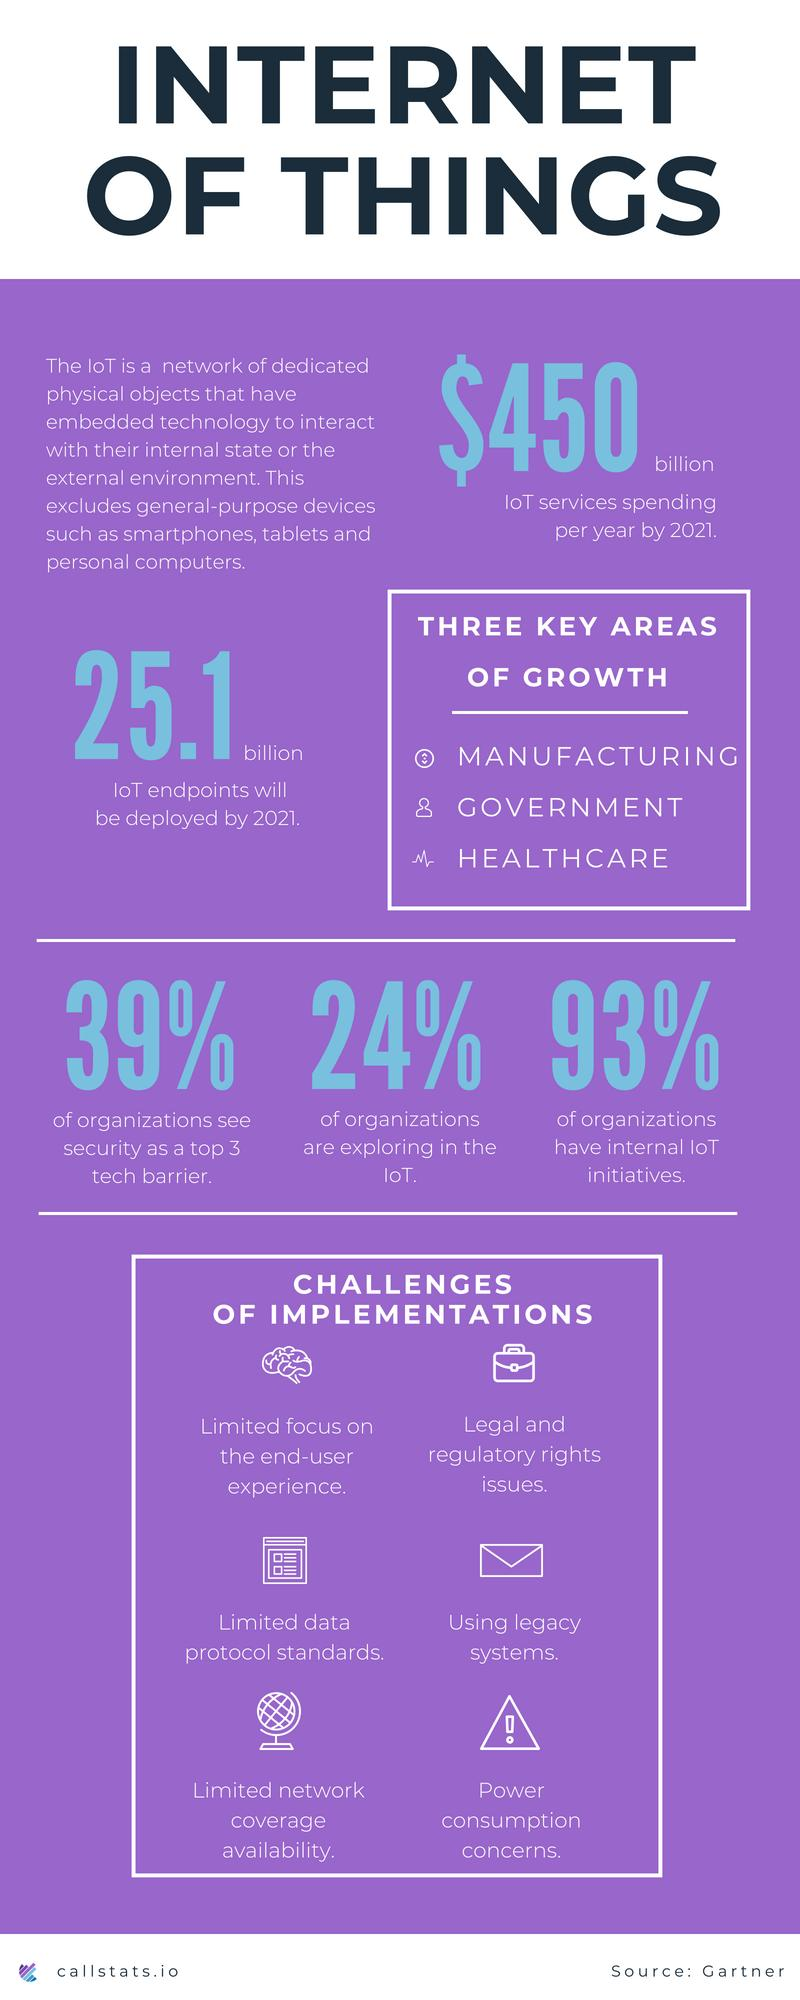Draw attention to some important aspects in this diagram. According to a significant percentage of organizations, security is considered one of the top 3 tech barriers they face. In the field of IoT, healthcare is a key area of growth beyond manufacturing and government. According to a recent survey, a staggering 93% of organizations have initiated internal Internet of Things (IoT) projects. By 2021, it is estimated that there will be approximately 25.1 billion IoT endpoints deployed globally. According to a recent survey, 24% of organizations are currently exploring the Internet of Things (IoT). 